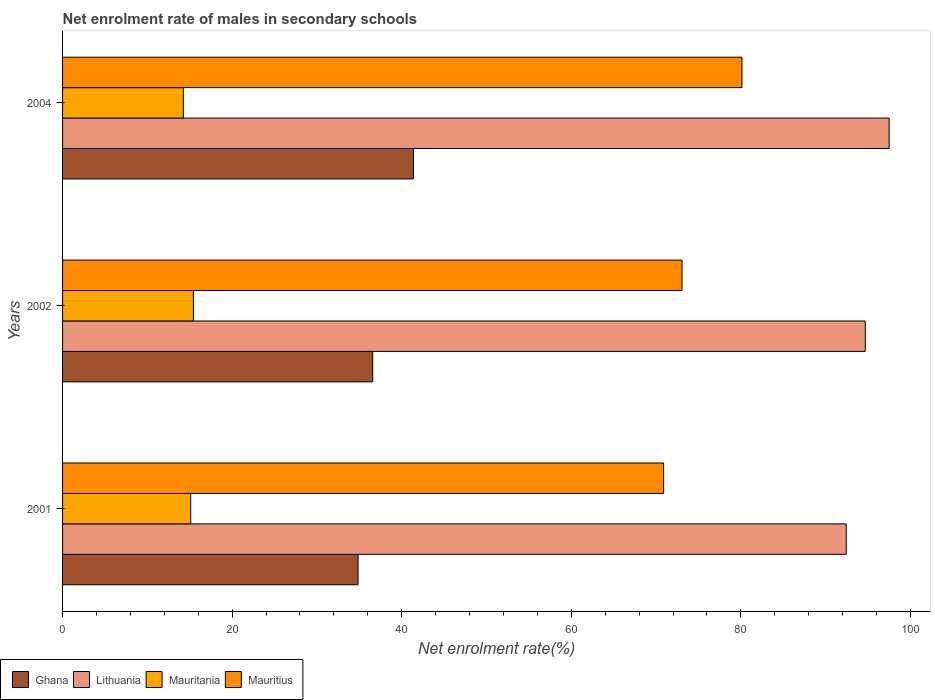How many different coloured bars are there?
Your response must be concise. 4. How many groups of bars are there?
Give a very brief answer. 3. Are the number of bars on each tick of the Y-axis equal?
Keep it short and to the point. Yes. How many bars are there on the 3rd tick from the top?
Keep it short and to the point. 4. What is the label of the 2nd group of bars from the top?
Ensure brevity in your answer.  2002. What is the net enrolment rate of males in secondary schools in Lithuania in 2002?
Offer a very short reply. 94.68. Across all years, what is the maximum net enrolment rate of males in secondary schools in Ghana?
Your answer should be compact. 41.38. Across all years, what is the minimum net enrolment rate of males in secondary schools in Lithuania?
Your answer should be very brief. 92.43. In which year was the net enrolment rate of males in secondary schools in Mauritania minimum?
Provide a short and direct response. 2004. What is the total net enrolment rate of males in secondary schools in Mauritius in the graph?
Offer a very short reply. 224.09. What is the difference between the net enrolment rate of males in secondary schools in Ghana in 2001 and that in 2004?
Keep it short and to the point. -6.53. What is the difference between the net enrolment rate of males in secondary schools in Mauritius in 2001 and the net enrolment rate of males in secondary schools in Lithuania in 2002?
Your answer should be very brief. -23.78. What is the average net enrolment rate of males in secondary schools in Ghana per year?
Offer a very short reply. 37.6. In the year 2001, what is the difference between the net enrolment rate of males in secondary schools in Lithuania and net enrolment rate of males in secondary schools in Mauritania?
Your answer should be very brief. 77.32. In how many years, is the net enrolment rate of males in secondary schools in Mauritius greater than 68 %?
Give a very brief answer. 3. What is the ratio of the net enrolment rate of males in secondary schools in Lithuania in 2001 to that in 2002?
Make the answer very short. 0.98. What is the difference between the highest and the second highest net enrolment rate of males in secondary schools in Ghana?
Make the answer very short. 4.8. What is the difference between the highest and the lowest net enrolment rate of males in secondary schools in Lithuania?
Your answer should be very brief. 5.06. In how many years, is the net enrolment rate of males in secondary schools in Mauritius greater than the average net enrolment rate of males in secondary schools in Mauritius taken over all years?
Your answer should be compact. 1. Is the sum of the net enrolment rate of males in secondary schools in Mauritania in 2001 and 2002 greater than the maximum net enrolment rate of males in secondary schools in Ghana across all years?
Give a very brief answer. No. What does the 1st bar from the top in 2002 represents?
Keep it short and to the point. Mauritius. What does the 4th bar from the bottom in 2001 represents?
Give a very brief answer. Mauritius. How many bars are there?
Your response must be concise. 12. How many years are there in the graph?
Your answer should be compact. 3. Are the values on the major ticks of X-axis written in scientific E-notation?
Ensure brevity in your answer.  No. How many legend labels are there?
Provide a succinct answer. 4. How are the legend labels stacked?
Give a very brief answer. Horizontal. What is the title of the graph?
Your response must be concise. Net enrolment rate of males in secondary schools. What is the label or title of the X-axis?
Keep it short and to the point. Net enrolment rate(%). What is the Net enrolment rate(%) of Ghana in 2001?
Your response must be concise. 34.85. What is the Net enrolment rate(%) of Lithuania in 2001?
Keep it short and to the point. 92.43. What is the Net enrolment rate(%) in Mauritania in 2001?
Your answer should be very brief. 15.11. What is the Net enrolment rate(%) of Mauritius in 2001?
Keep it short and to the point. 70.89. What is the Net enrolment rate(%) in Ghana in 2002?
Your answer should be very brief. 36.58. What is the Net enrolment rate(%) in Lithuania in 2002?
Your response must be concise. 94.68. What is the Net enrolment rate(%) of Mauritania in 2002?
Make the answer very short. 15.43. What is the Net enrolment rate(%) in Mauritius in 2002?
Give a very brief answer. 73.06. What is the Net enrolment rate(%) in Ghana in 2004?
Your response must be concise. 41.38. What is the Net enrolment rate(%) of Lithuania in 2004?
Keep it short and to the point. 97.49. What is the Net enrolment rate(%) of Mauritania in 2004?
Make the answer very short. 14.25. What is the Net enrolment rate(%) in Mauritius in 2004?
Provide a short and direct response. 80.13. Across all years, what is the maximum Net enrolment rate(%) in Ghana?
Offer a terse response. 41.38. Across all years, what is the maximum Net enrolment rate(%) of Lithuania?
Provide a short and direct response. 97.49. Across all years, what is the maximum Net enrolment rate(%) in Mauritania?
Make the answer very short. 15.43. Across all years, what is the maximum Net enrolment rate(%) of Mauritius?
Give a very brief answer. 80.13. Across all years, what is the minimum Net enrolment rate(%) of Ghana?
Your answer should be compact. 34.85. Across all years, what is the minimum Net enrolment rate(%) in Lithuania?
Keep it short and to the point. 92.43. Across all years, what is the minimum Net enrolment rate(%) in Mauritania?
Give a very brief answer. 14.25. Across all years, what is the minimum Net enrolment rate(%) in Mauritius?
Offer a very short reply. 70.89. What is the total Net enrolment rate(%) in Ghana in the graph?
Keep it short and to the point. 112.81. What is the total Net enrolment rate(%) of Lithuania in the graph?
Your answer should be very brief. 284.6. What is the total Net enrolment rate(%) of Mauritania in the graph?
Your answer should be very brief. 44.79. What is the total Net enrolment rate(%) of Mauritius in the graph?
Give a very brief answer. 224.09. What is the difference between the Net enrolment rate(%) of Ghana in 2001 and that in 2002?
Make the answer very short. -1.73. What is the difference between the Net enrolment rate(%) in Lithuania in 2001 and that in 2002?
Ensure brevity in your answer.  -2.24. What is the difference between the Net enrolment rate(%) in Mauritania in 2001 and that in 2002?
Make the answer very short. -0.32. What is the difference between the Net enrolment rate(%) in Mauritius in 2001 and that in 2002?
Your answer should be compact. -2.17. What is the difference between the Net enrolment rate(%) in Ghana in 2001 and that in 2004?
Provide a succinct answer. -6.53. What is the difference between the Net enrolment rate(%) of Lithuania in 2001 and that in 2004?
Your answer should be very brief. -5.06. What is the difference between the Net enrolment rate(%) in Mauritania in 2001 and that in 2004?
Your answer should be compact. 0.87. What is the difference between the Net enrolment rate(%) in Mauritius in 2001 and that in 2004?
Keep it short and to the point. -9.24. What is the difference between the Net enrolment rate(%) in Ghana in 2002 and that in 2004?
Make the answer very short. -4.8. What is the difference between the Net enrolment rate(%) in Lithuania in 2002 and that in 2004?
Your response must be concise. -2.82. What is the difference between the Net enrolment rate(%) in Mauritania in 2002 and that in 2004?
Give a very brief answer. 1.19. What is the difference between the Net enrolment rate(%) of Mauritius in 2002 and that in 2004?
Provide a succinct answer. -7.07. What is the difference between the Net enrolment rate(%) in Ghana in 2001 and the Net enrolment rate(%) in Lithuania in 2002?
Provide a short and direct response. -59.82. What is the difference between the Net enrolment rate(%) in Ghana in 2001 and the Net enrolment rate(%) in Mauritania in 2002?
Offer a terse response. 19.42. What is the difference between the Net enrolment rate(%) of Ghana in 2001 and the Net enrolment rate(%) of Mauritius in 2002?
Keep it short and to the point. -38.21. What is the difference between the Net enrolment rate(%) in Lithuania in 2001 and the Net enrolment rate(%) in Mauritania in 2002?
Your answer should be very brief. 77. What is the difference between the Net enrolment rate(%) in Lithuania in 2001 and the Net enrolment rate(%) in Mauritius in 2002?
Provide a succinct answer. 19.37. What is the difference between the Net enrolment rate(%) of Mauritania in 2001 and the Net enrolment rate(%) of Mauritius in 2002?
Keep it short and to the point. -57.95. What is the difference between the Net enrolment rate(%) of Ghana in 2001 and the Net enrolment rate(%) of Lithuania in 2004?
Give a very brief answer. -62.64. What is the difference between the Net enrolment rate(%) in Ghana in 2001 and the Net enrolment rate(%) in Mauritania in 2004?
Offer a terse response. 20.61. What is the difference between the Net enrolment rate(%) of Ghana in 2001 and the Net enrolment rate(%) of Mauritius in 2004?
Provide a short and direct response. -45.28. What is the difference between the Net enrolment rate(%) in Lithuania in 2001 and the Net enrolment rate(%) in Mauritania in 2004?
Offer a terse response. 78.18. What is the difference between the Net enrolment rate(%) in Lithuania in 2001 and the Net enrolment rate(%) in Mauritius in 2004?
Your response must be concise. 12.3. What is the difference between the Net enrolment rate(%) in Mauritania in 2001 and the Net enrolment rate(%) in Mauritius in 2004?
Give a very brief answer. -65.02. What is the difference between the Net enrolment rate(%) in Ghana in 2002 and the Net enrolment rate(%) in Lithuania in 2004?
Ensure brevity in your answer.  -60.91. What is the difference between the Net enrolment rate(%) in Ghana in 2002 and the Net enrolment rate(%) in Mauritania in 2004?
Your answer should be compact. 22.33. What is the difference between the Net enrolment rate(%) of Ghana in 2002 and the Net enrolment rate(%) of Mauritius in 2004?
Keep it short and to the point. -43.55. What is the difference between the Net enrolment rate(%) in Lithuania in 2002 and the Net enrolment rate(%) in Mauritania in 2004?
Ensure brevity in your answer.  80.43. What is the difference between the Net enrolment rate(%) in Lithuania in 2002 and the Net enrolment rate(%) in Mauritius in 2004?
Ensure brevity in your answer.  14.54. What is the difference between the Net enrolment rate(%) of Mauritania in 2002 and the Net enrolment rate(%) of Mauritius in 2004?
Your answer should be compact. -64.7. What is the average Net enrolment rate(%) of Ghana per year?
Provide a succinct answer. 37.6. What is the average Net enrolment rate(%) in Lithuania per year?
Keep it short and to the point. 94.87. What is the average Net enrolment rate(%) of Mauritania per year?
Your response must be concise. 14.93. What is the average Net enrolment rate(%) of Mauritius per year?
Offer a very short reply. 74.7. In the year 2001, what is the difference between the Net enrolment rate(%) of Ghana and Net enrolment rate(%) of Lithuania?
Give a very brief answer. -57.58. In the year 2001, what is the difference between the Net enrolment rate(%) of Ghana and Net enrolment rate(%) of Mauritania?
Ensure brevity in your answer.  19.74. In the year 2001, what is the difference between the Net enrolment rate(%) in Ghana and Net enrolment rate(%) in Mauritius?
Your answer should be compact. -36.04. In the year 2001, what is the difference between the Net enrolment rate(%) of Lithuania and Net enrolment rate(%) of Mauritania?
Offer a terse response. 77.32. In the year 2001, what is the difference between the Net enrolment rate(%) in Lithuania and Net enrolment rate(%) in Mauritius?
Provide a short and direct response. 21.54. In the year 2001, what is the difference between the Net enrolment rate(%) of Mauritania and Net enrolment rate(%) of Mauritius?
Keep it short and to the point. -55.78. In the year 2002, what is the difference between the Net enrolment rate(%) of Ghana and Net enrolment rate(%) of Lithuania?
Your answer should be very brief. -58.09. In the year 2002, what is the difference between the Net enrolment rate(%) of Ghana and Net enrolment rate(%) of Mauritania?
Offer a very short reply. 21.15. In the year 2002, what is the difference between the Net enrolment rate(%) of Ghana and Net enrolment rate(%) of Mauritius?
Your answer should be compact. -36.48. In the year 2002, what is the difference between the Net enrolment rate(%) in Lithuania and Net enrolment rate(%) in Mauritania?
Provide a short and direct response. 79.24. In the year 2002, what is the difference between the Net enrolment rate(%) of Lithuania and Net enrolment rate(%) of Mauritius?
Your answer should be very brief. 21.61. In the year 2002, what is the difference between the Net enrolment rate(%) in Mauritania and Net enrolment rate(%) in Mauritius?
Your response must be concise. -57.63. In the year 2004, what is the difference between the Net enrolment rate(%) in Ghana and Net enrolment rate(%) in Lithuania?
Ensure brevity in your answer.  -56.11. In the year 2004, what is the difference between the Net enrolment rate(%) in Ghana and Net enrolment rate(%) in Mauritania?
Provide a short and direct response. 27.13. In the year 2004, what is the difference between the Net enrolment rate(%) of Ghana and Net enrolment rate(%) of Mauritius?
Ensure brevity in your answer.  -38.75. In the year 2004, what is the difference between the Net enrolment rate(%) of Lithuania and Net enrolment rate(%) of Mauritania?
Your response must be concise. 83.25. In the year 2004, what is the difference between the Net enrolment rate(%) of Lithuania and Net enrolment rate(%) of Mauritius?
Make the answer very short. 17.36. In the year 2004, what is the difference between the Net enrolment rate(%) of Mauritania and Net enrolment rate(%) of Mauritius?
Ensure brevity in your answer.  -65.89. What is the ratio of the Net enrolment rate(%) in Ghana in 2001 to that in 2002?
Your response must be concise. 0.95. What is the ratio of the Net enrolment rate(%) of Lithuania in 2001 to that in 2002?
Your answer should be compact. 0.98. What is the ratio of the Net enrolment rate(%) of Mauritania in 2001 to that in 2002?
Your answer should be very brief. 0.98. What is the ratio of the Net enrolment rate(%) of Mauritius in 2001 to that in 2002?
Ensure brevity in your answer.  0.97. What is the ratio of the Net enrolment rate(%) of Ghana in 2001 to that in 2004?
Keep it short and to the point. 0.84. What is the ratio of the Net enrolment rate(%) of Lithuania in 2001 to that in 2004?
Make the answer very short. 0.95. What is the ratio of the Net enrolment rate(%) of Mauritania in 2001 to that in 2004?
Your answer should be very brief. 1.06. What is the ratio of the Net enrolment rate(%) of Mauritius in 2001 to that in 2004?
Your answer should be very brief. 0.88. What is the ratio of the Net enrolment rate(%) of Ghana in 2002 to that in 2004?
Your answer should be compact. 0.88. What is the ratio of the Net enrolment rate(%) of Lithuania in 2002 to that in 2004?
Provide a short and direct response. 0.97. What is the ratio of the Net enrolment rate(%) in Mauritania in 2002 to that in 2004?
Keep it short and to the point. 1.08. What is the ratio of the Net enrolment rate(%) of Mauritius in 2002 to that in 2004?
Your response must be concise. 0.91. What is the difference between the highest and the second highest Net enrolment rate(%) in Ghana?
Your answer should be very brief. 4.8. What is the difference between the highest and the second highest Net enrolment rate(%) in Lithuania?
Your response must be concise. 2.82. What is the difference between the highest and the second highest Net enrolment rate(%) of Mauritania?
Provide a short and direct response. 0.32. What is the difference between the highest and the second highest Net enrolment rate(%) of Mauritius?
Give a very brief answer. 7.07. What is the difference between the highest and the lowest Net enrolment rate(%) in Ghana?
Offer a very short reply. 6.53. What is the difference between the highest and the lowest Net enrolment rate(%) of Lithuania?
Make the answer very short. 5.06. What is the difference between the highest and the lowest Net enrolment rate(%) of Mauritania?
Your response must be concise. 1.19. What is the difference between the highest and the lowest Net enrolment rate(%) of Mauritius?
Offer a terse response. 9.24. 